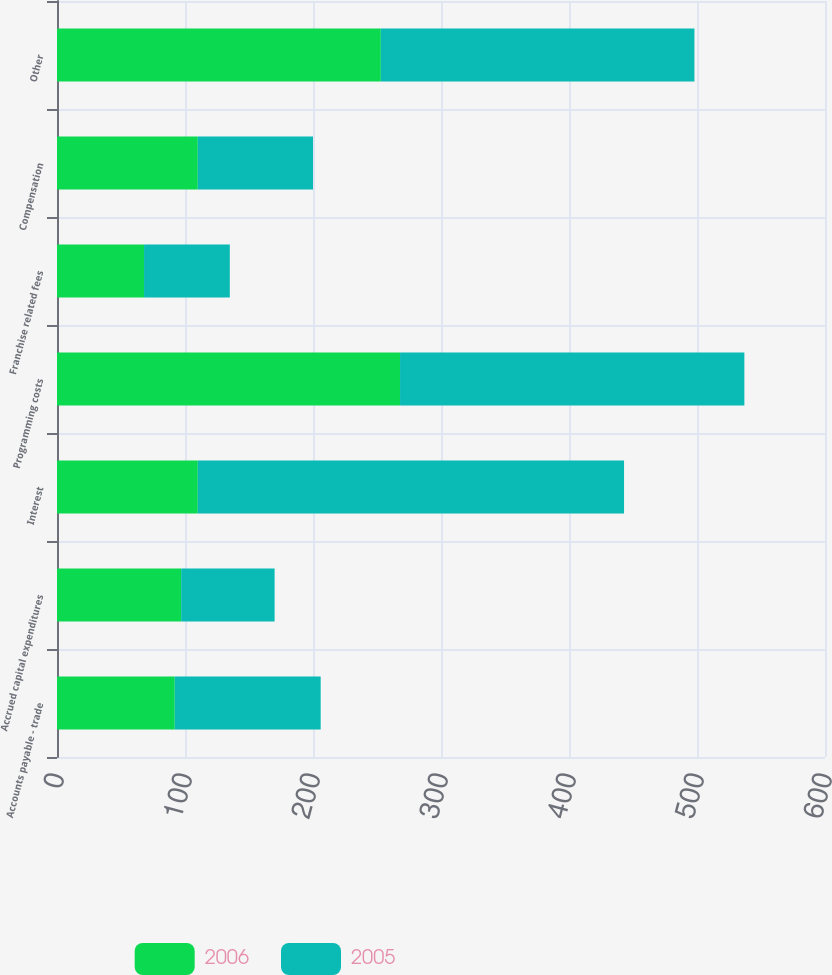<chart> <loc_0><loc_0><loc_500><loc_500><stacked_bar_chart><ecel><fcel>Accounts payable - trade<fcel>Accrued capital expenditures<fcel>Interest<fcel>Programming costs<fcel>Franchise related fees<fcel>Compensation<fcel>Other<nl><fcel>2006<fcel>92<fcel>97<fcel>110<fcel>268<fcel>68<fcel>110<fcel>253<nl><fcel>2005<fcel>114<fcel>73<fcel>333<fcel>269<fcel>67<fcel>90<fcel>245<nl></chart> 